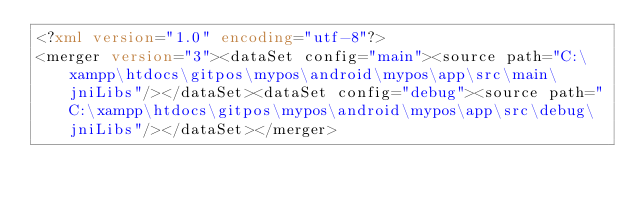Convert code to text. <code><loc_0><loc_0><loc_500><loc_500><_XML_><?xml version="1.0" encoding="utf-8"?>
<merger version="3"><dataSet config="main"><source path="C:\xampp\htdocs\gitpos\mypos\android\mypos\app\src\main\jniLibs"/></dataSet><dataSet config="debug"><source path="C:\xampp\htdocs\gitpos\mypos\android\mypos\app\src\debug\jniLibs"/></dataSet></merger></code> 